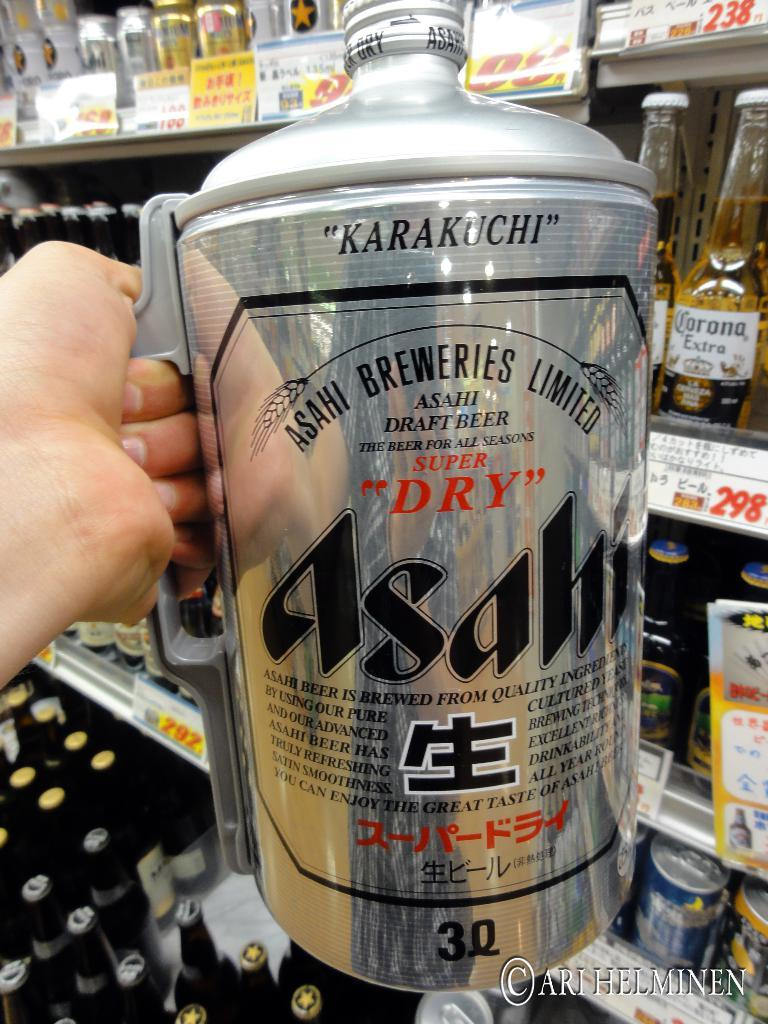<image>
Summarize the visual content of the image. A mug from the Asahi Breweries Limited company is available in a 3Q size. 